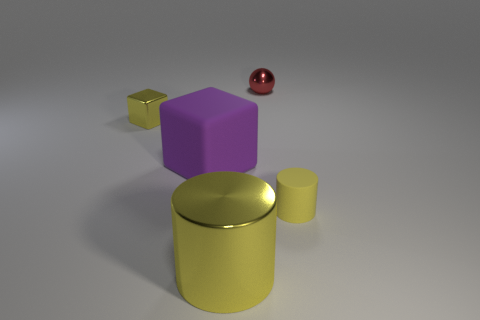There is a tiny shiny thing that is the same color as the small rubber cylinder; what shape is it?
Your response must be concise. Cube. Are there any small yellow matte objects that have the same shape as the big purple rubber thing?
Ensure brevity in your answer.  No. There is a cylinder in front of the cylinder to the right of the tiny red metal object; how many tiny shiny balls are left of it?
Provide a short and direct response. 0. There is a metallic cylinder; does it have the same color as the tiny object that is to the left of the red metal sphere?
Offer a terse response. Yes. What number of things are shiny things in front of the small yellow shiny block or objects that are behind the tiny yellow cylinder?
Offer a terse response. 4. Are there more things that are in front of the red shiny thing than yellow matte cylinders behind the small block?
Ensure brevity in your answer.  Yes. What is the material of the yellow cylinder right of the big thing that is in front of the cylinder that is behind the big metallic thing?
Give a very brief answer. Rubber. There is a rubber thing left of the small matte cylinder; is its shape the same as the tiny shiny object in front of the small red ball?
Your answer should be very brief. Yes. Are there any purple metal cubes that have the same size as the red sphere?
Offer a terse response. No. What number of red objects are large metallic objects or small metallic objects?
Provide a succinct answer. 1. 